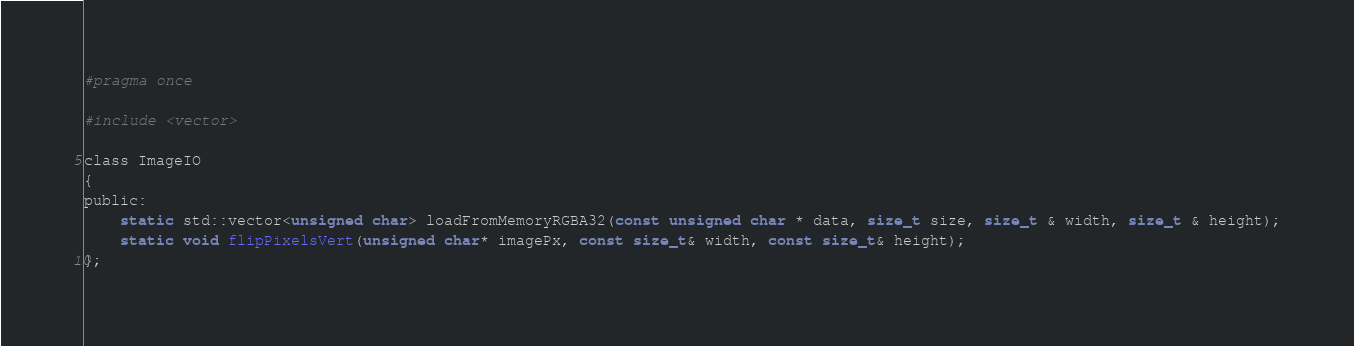<code> <loc_0><loc_0><loc_500><loc_500><_C_>#pragma once

#include <vector>

class ImageIO
{
public:
	static std::vector<unsigned char> loadFromMemoryRGBA32(const unsigned char * data, size_t size, size_t & width, size_t & height);
	static void flipPixelsVert(unsigned char* imagePx, const size_t& width, const size_t& height);
};</code> 